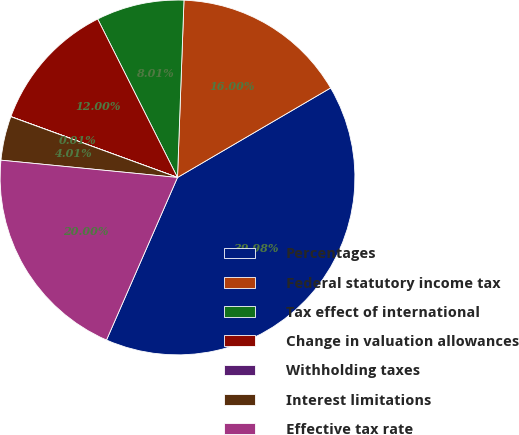<chart> <loc_0><loc_0><loc_500><loc_500><pie_chart><fcel>Percentages<fcel>Federal statutory income tax<fcel>Tax effect of international<fcel>Change in valuation allowances<fcel>Withholding taxes<fcel>Interest limitations<fcel>Effective tax rate<nl><fcel>39.98%<fcel>16.0%<fcel>8.01%<fcel>12.0%<fcel>0.01%<fcel>4.01%<fcel>20.0%<nl></chart> 